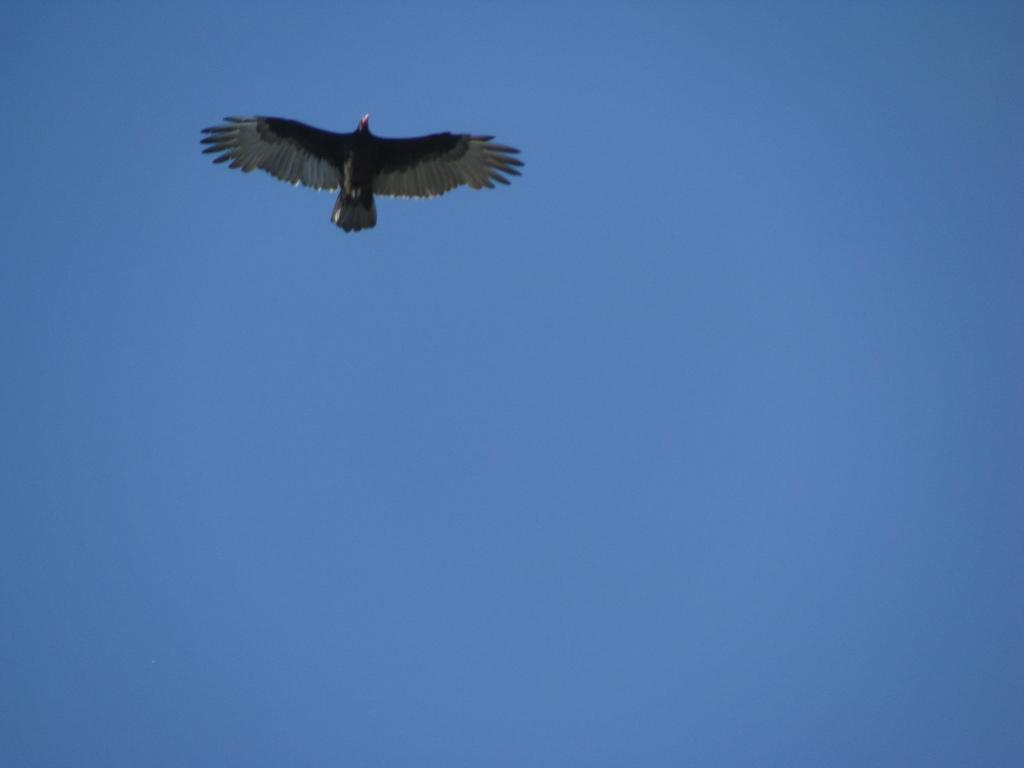What is the main subject of the image? There is a bird flying in the air. What can be seen in the background of the image? The sky is visible in the background of the image. What type of building can be seen in the image? There is no building present in the image; it features a bird flying in the air with the sky as the background. How many cards are visible in the image? There are no cards present in the image. 